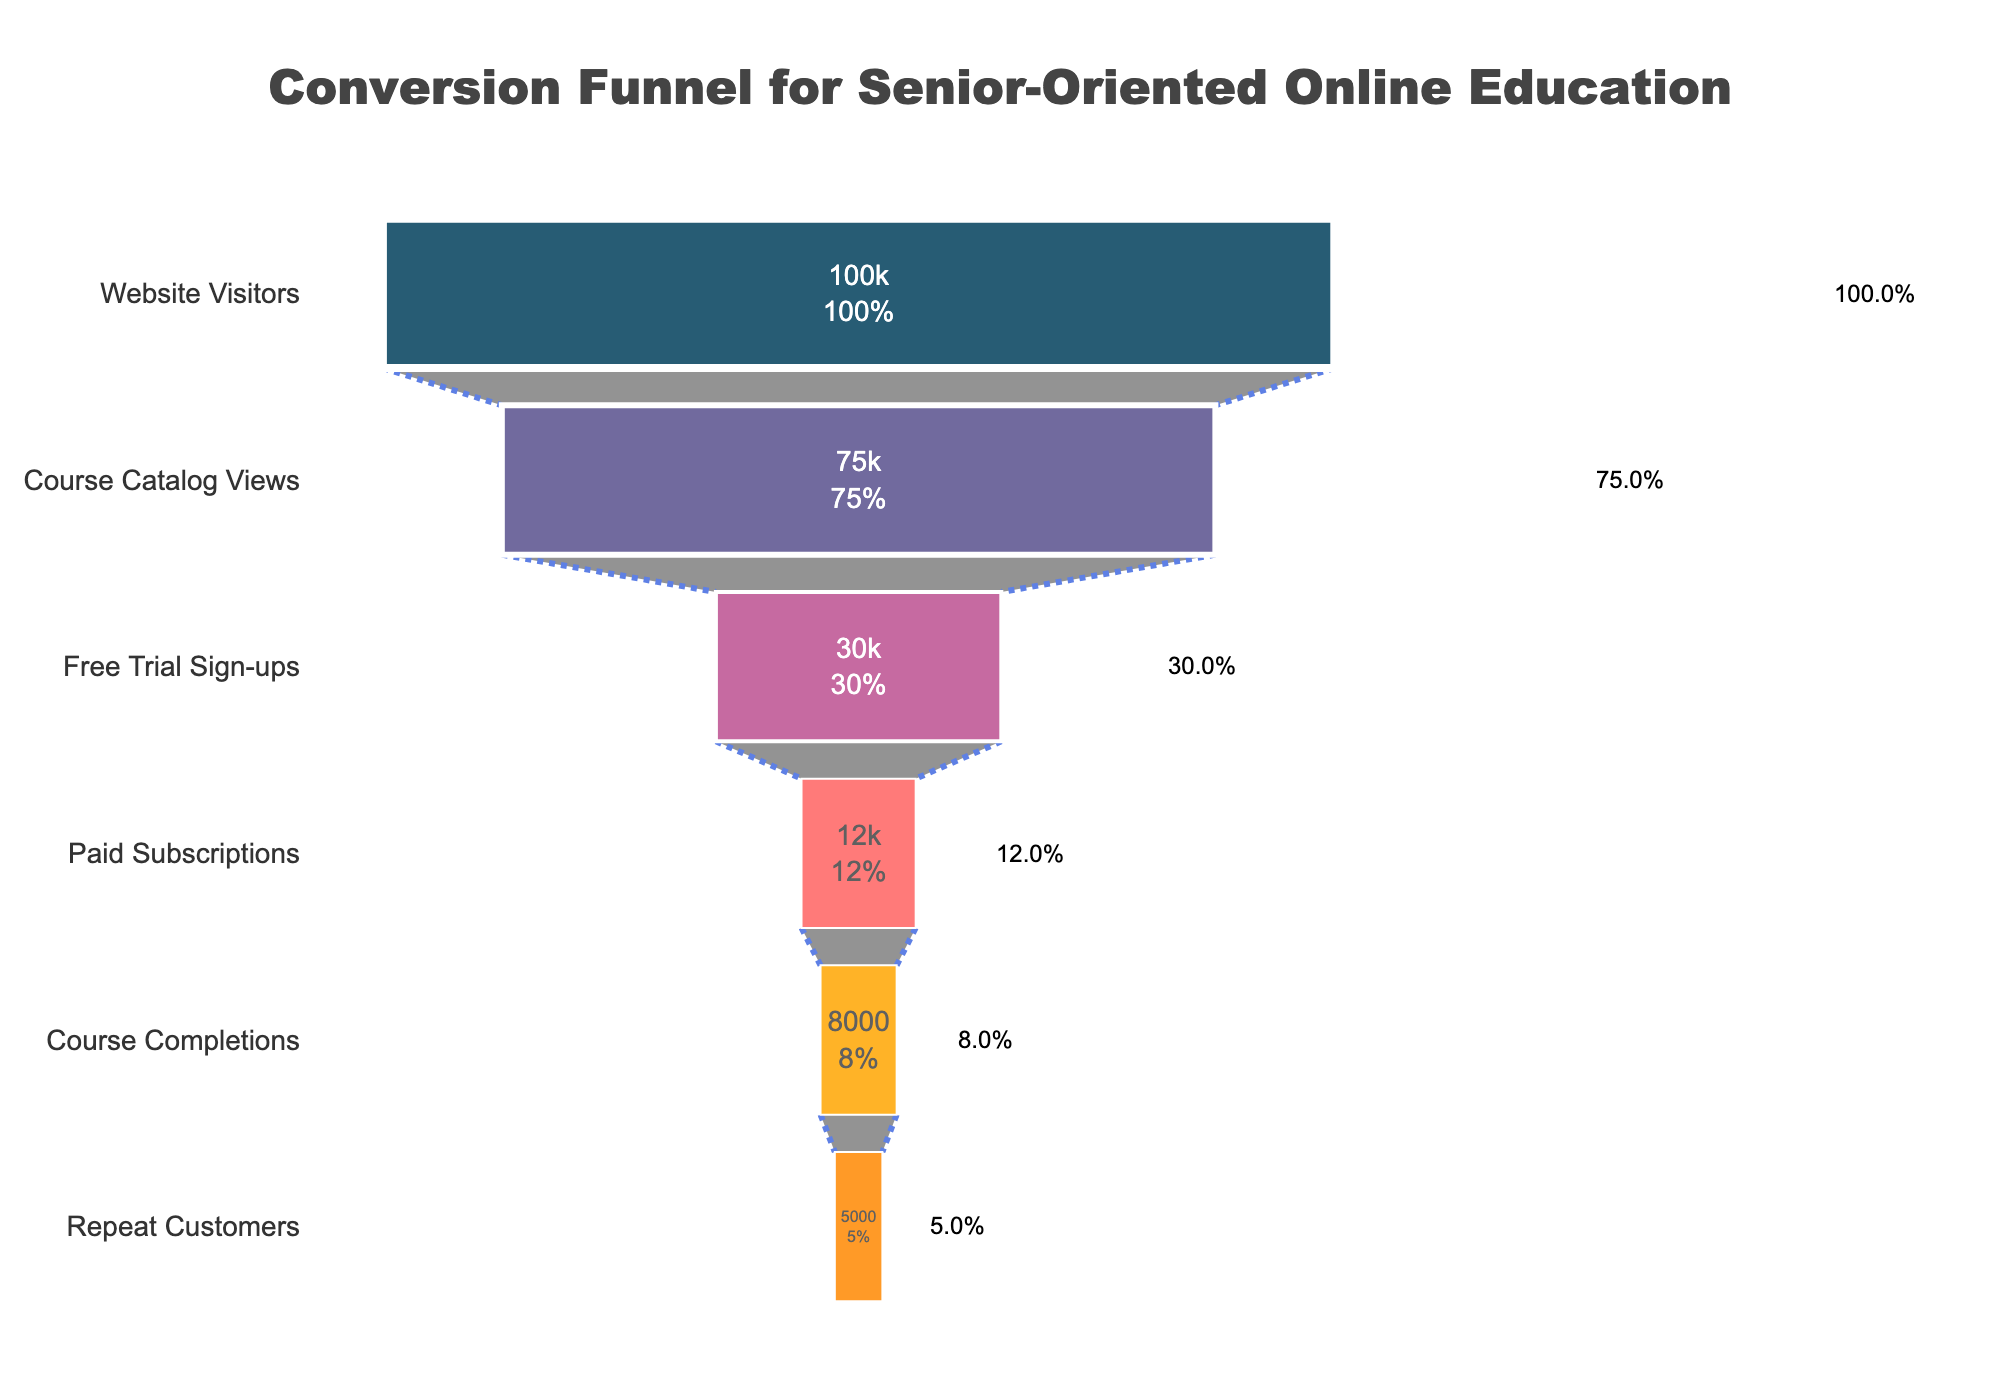What's the title of the chart? To find the title, look at the top of the chart, where it is usually placed.
Answer: Conversion Funnel for Senior-Oriented Online Education How many stages are there in the funnel? Count the total number of stages listed in the funnel chart.
Answer: 6 What percentage of users who view the course catalog sign up for the free trial? Divide the number of Free Trial Sign-ups by the number of Course Catalog Views and multiply by 100: (30000 / 75000) * 100.
Answer: 40% What is the difference in the number of users between Paid Subscriptions and Course Completions? Subtract the number of Course Completions from Paid Subscriptions: 12000 - 8000.
Answer: 4000 Which stage has the highest drop-off in users compared to the previous stage? Calculate the difference between consecutive stages and find the maximum drop-off. The biggest differences are between Course Catalog Views and Free Trial Sign-ups: 75000 - 30000.
Answer: Course Catalog Views to Free Trial Sign-ups What percentage of the initial website visitors become repeat customers? Divide the number of Repeat Customers by the number of Website Visitors and multiply by 100: (5000 / 100000) * 100.
Answer: 5% How many users sign up for the free trial but do not convert to paid subscribers? Subtract Paid Subscriptions from Free Trial Sign-ups: 30000 - 12000.
Answer: 18000 What color represents the stage with the Paid Subscriptions? Look at the corresponding color in the funnel chart.
Answer: orange (hex code "#ffa600") Is the number of repeat customers higher or lower than the number of course completions? Compare the number of users between Repeat Customers and Course Completions.
Answer: Lower What stage accounts for 12% of the initial users? Identify the stage whose users make up 12% of 100000 Website Visitors, which means 12000 users.
Answer: Paid Subscriptions 